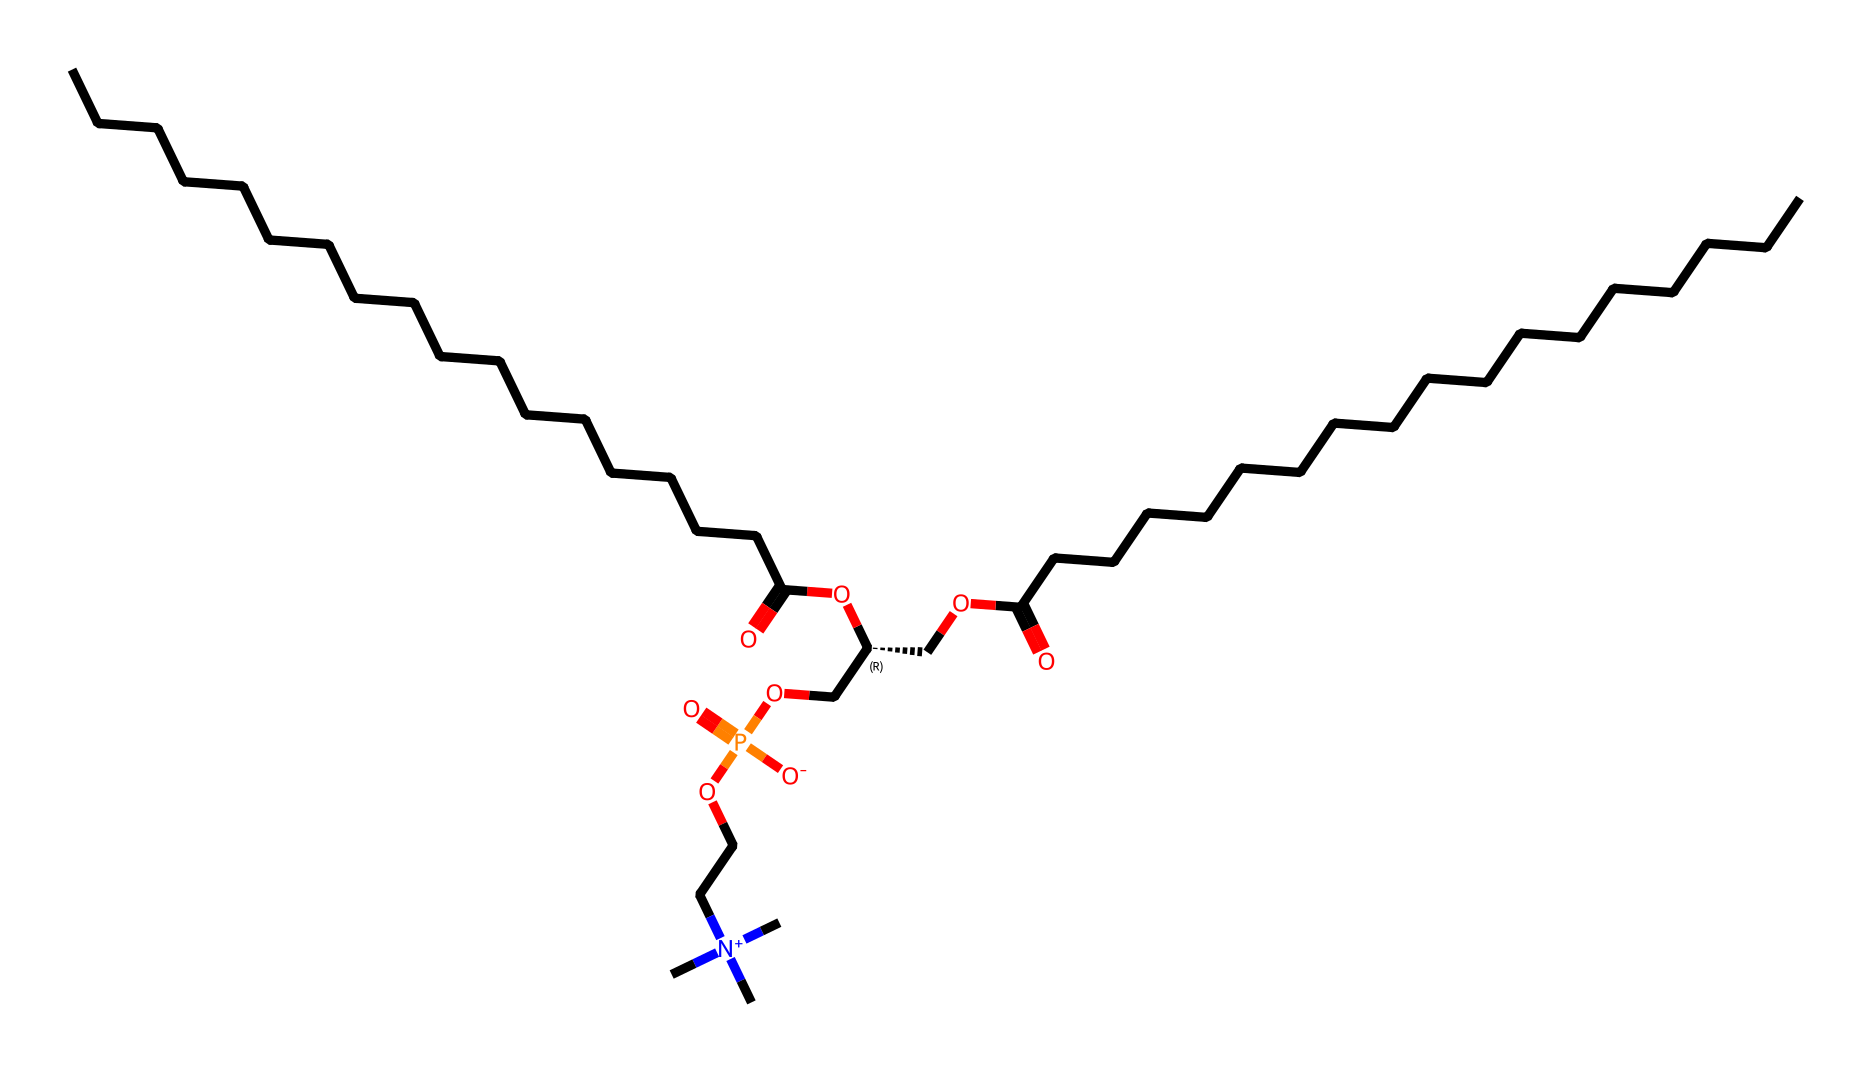how many carbon atoms are in lecithin? By analyzing the SMILES representation, we can count the number of 'C' characters which denote carbon atoms. There are 36 carbon atoms present in the chemical structure.
Answer: 36 what type of surfactant is lecithin? Lecithin acts as an amphiphilic surfactant due to its structure containing both hydrophilic (water-attracting) and hydrophobic (water-repelling) parts.
Answer: amphiphilic what functional groups are present in lecithin? In the provided structure, we can identify ester groups from the C(=O)OC segments, and phosphate groups from the COP(=O) part, which also indicates it is a phospholipid.
Answer: ester and phosphate how many nitrogen atoms are there in lecithin? Counting the 'N' symbols in the SMILES structure reveals there are two nitrogen atoms present within the chemical structure indicating the presence of quaternary ammonium.
Answer: 2 what molecular feature makes lecithin effective in skin care products? Lecithin's amphiphilic nature allows it to effectively decrease surface tension, enabling it to improve skin hydration and act as an emulsifier, blending oil and water components in formulations.
Answer: amphiphilic nature what is the role of phosphate in lecithin? The phosphate group contributes to the hydrophilic properties of lecithin, which enhances its ability to interact with water and maintain skin hydration, a key aspect of its function in skin care products.
Answer: hydration 